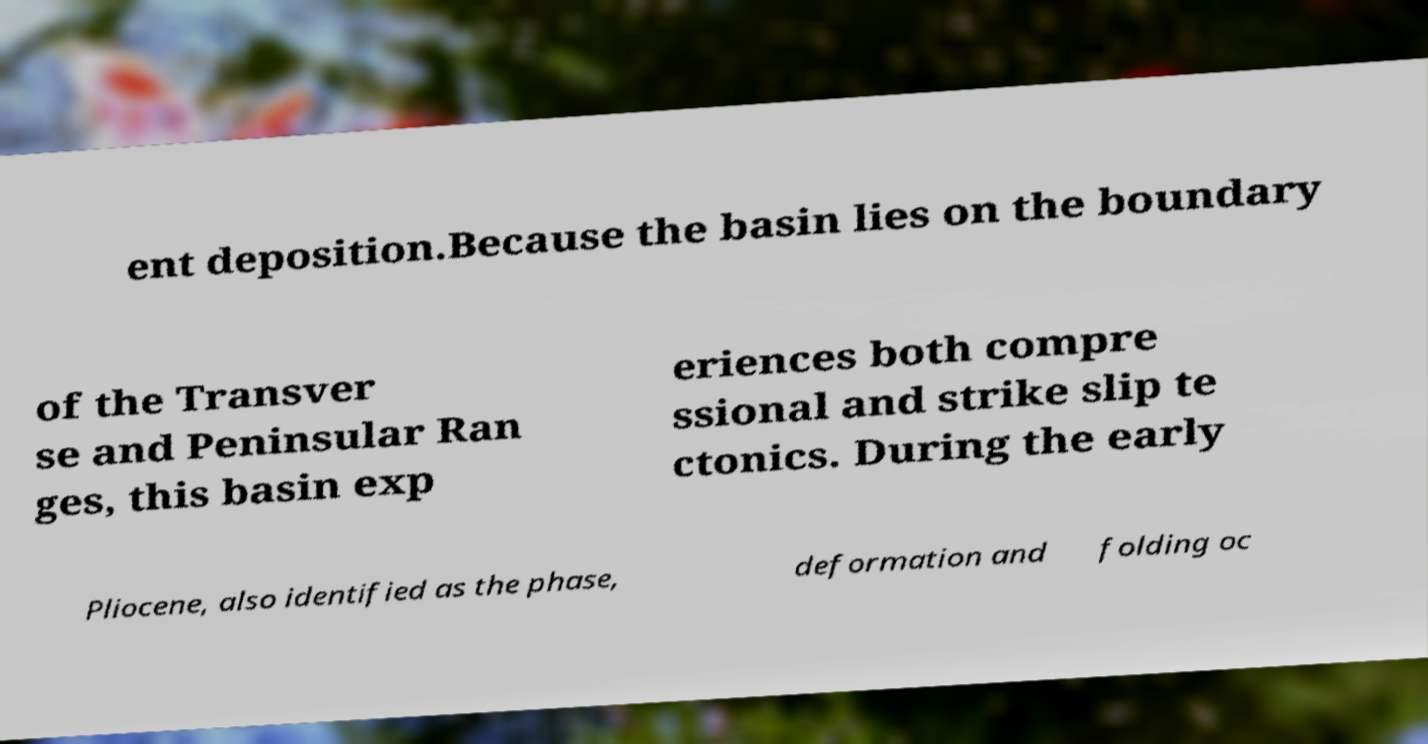Can you accurately transcribe the text from the provided image for me? ent deposition.Because the basin lies on the boundary of the Transver se and Peninsular Ran ges, this basin exp eriences both compre ssional and strike slip te ctonics. During the early Pliocene, also identified as the phase, deformation and folding oc 